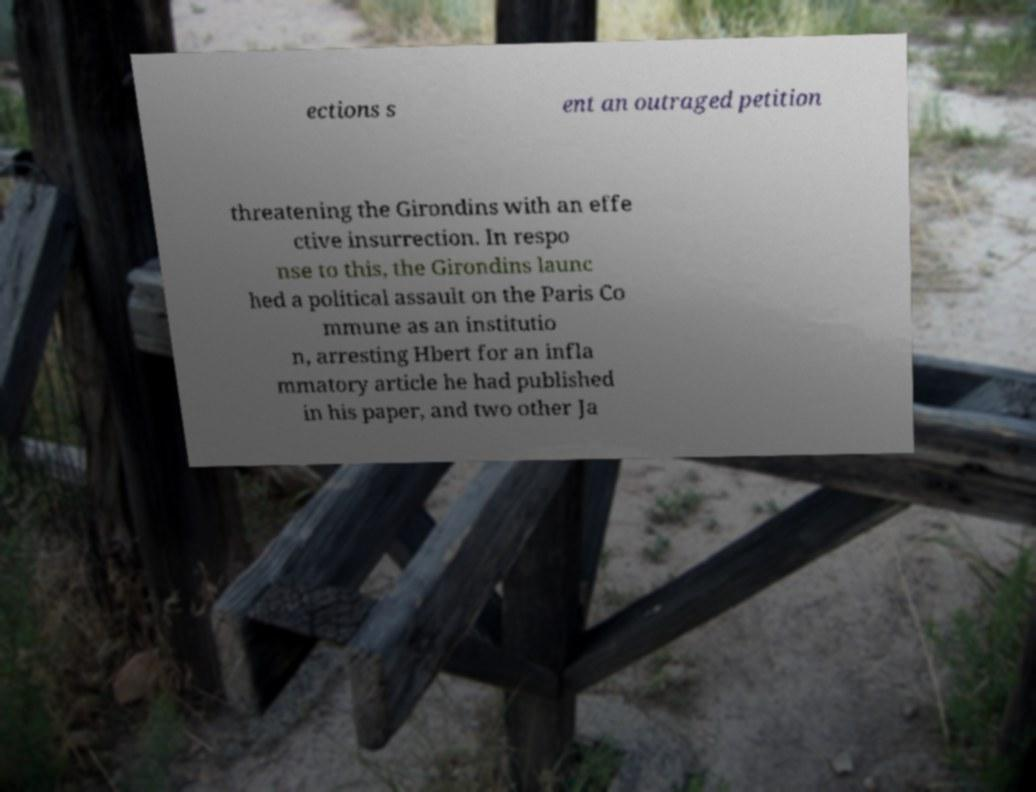Can you accurately transcribe the text from the provided image for me? ections s ent an outraged petition threatening the Girondins with an effe ctive insurrection. In respo nse to this, the Girondins launc hed a political assault on the Paris Co mmune as an institutio n, arresting Hbert for an infla mmatory article he had published in his paper, and two other Ja 